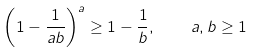Convert formula to latex. <formula><loc_0><loc_0><loc_500><loc_500>\left ( 1 - \frac { 1 } { a b } \right ) ^ { a } \geq 1 - \frac { 1 } { b } , \quad a , b \geq 1</formula> 